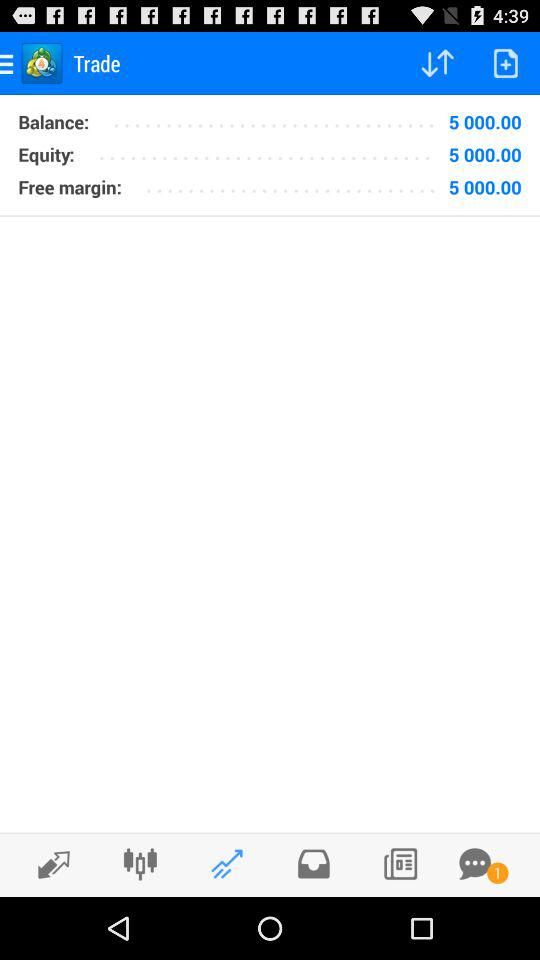How much is the free margin? The free margin is 5000.00. 